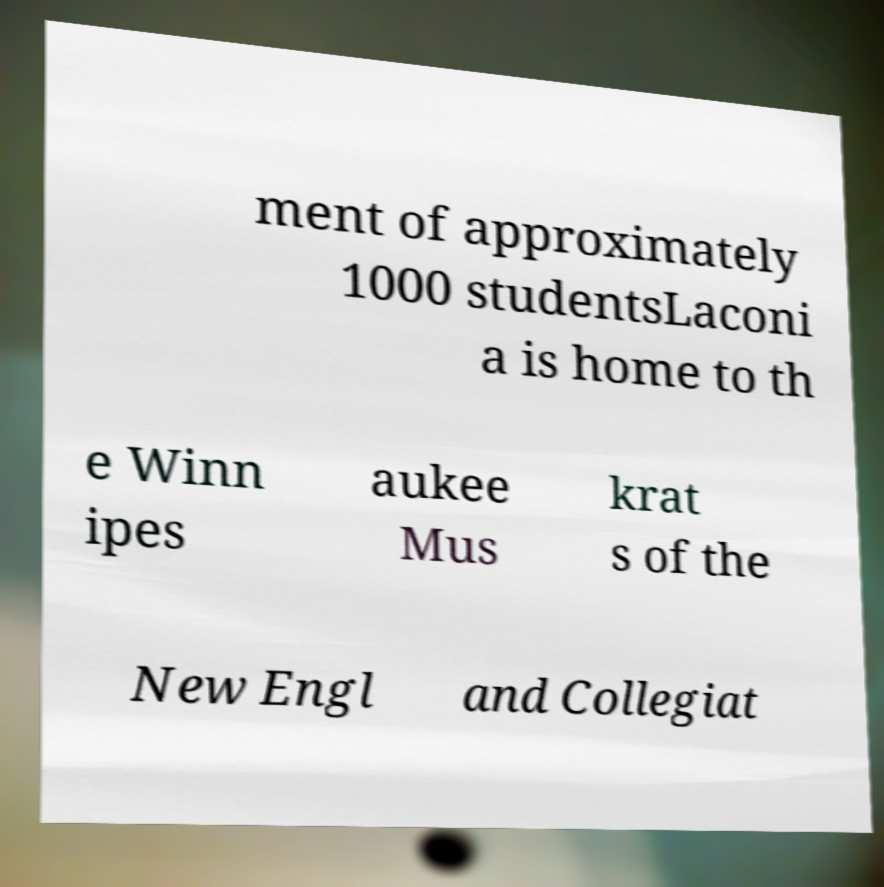For documentation purposes, I need the text within this image transcribed. Could you provide that? ment of approximately 1000 studentsLaconi a is home to th e Winn ipes aukee Mus krat s of the New Engl and Collegiat 